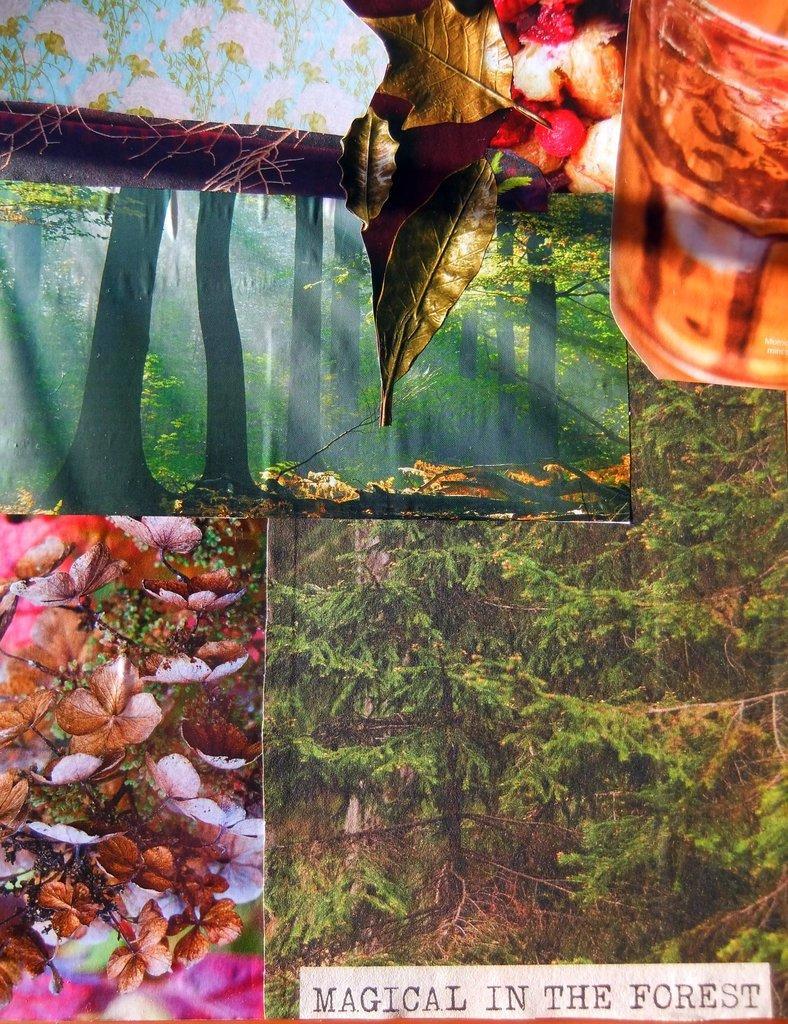Describe this image in one or two sentences. In this picture I can see there is a collage of images and there are flowers, plants, trees and there is a glass of wine and there is something written at the bottom right side of the image. 